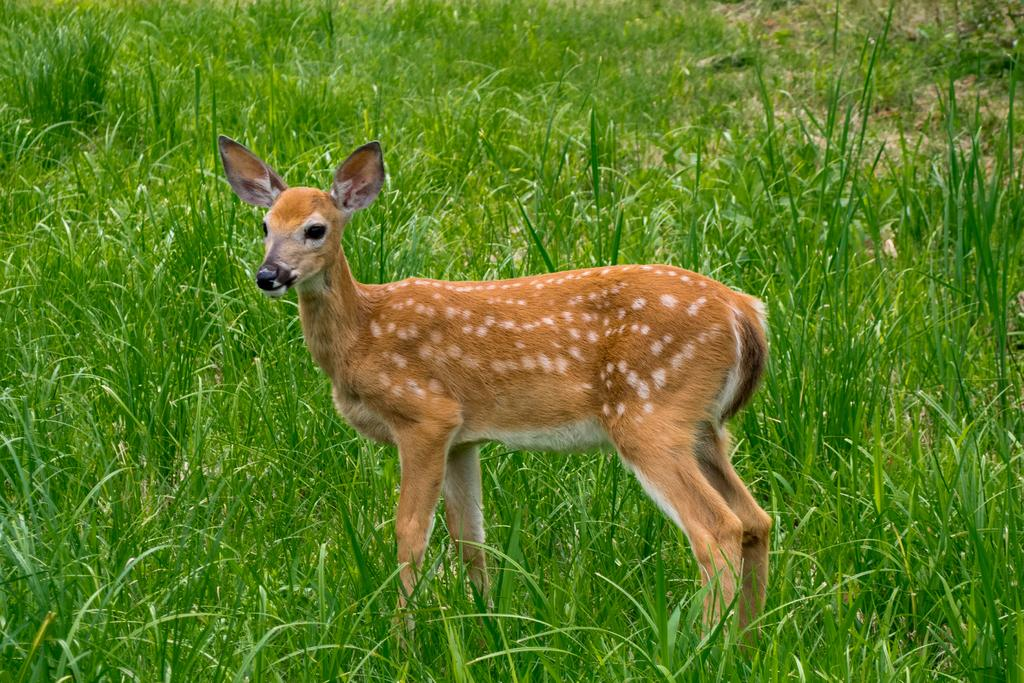What animal is present in the image? There is a deer in the image. What is the deer's position in the image? The deer is standing on the ground. What type of vegetation can be seen on the left side of the image? There is grass visible on the left side of the image. Who is the owner of the deer in the image? There is no indication in the image that the deer has an owner, as deer are wild animals and not typically owned by individuals. 